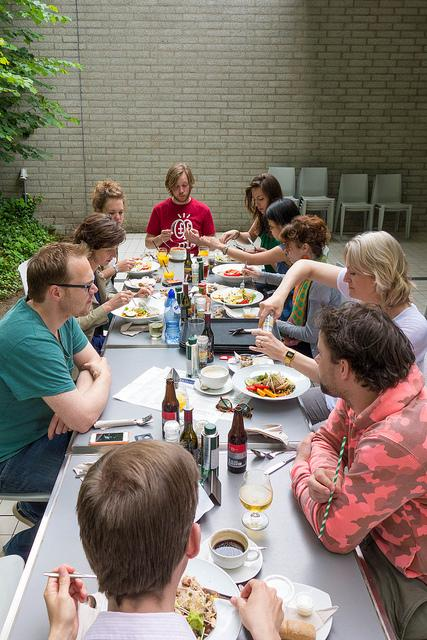Why does the person with the green shirt have no food? allergic 